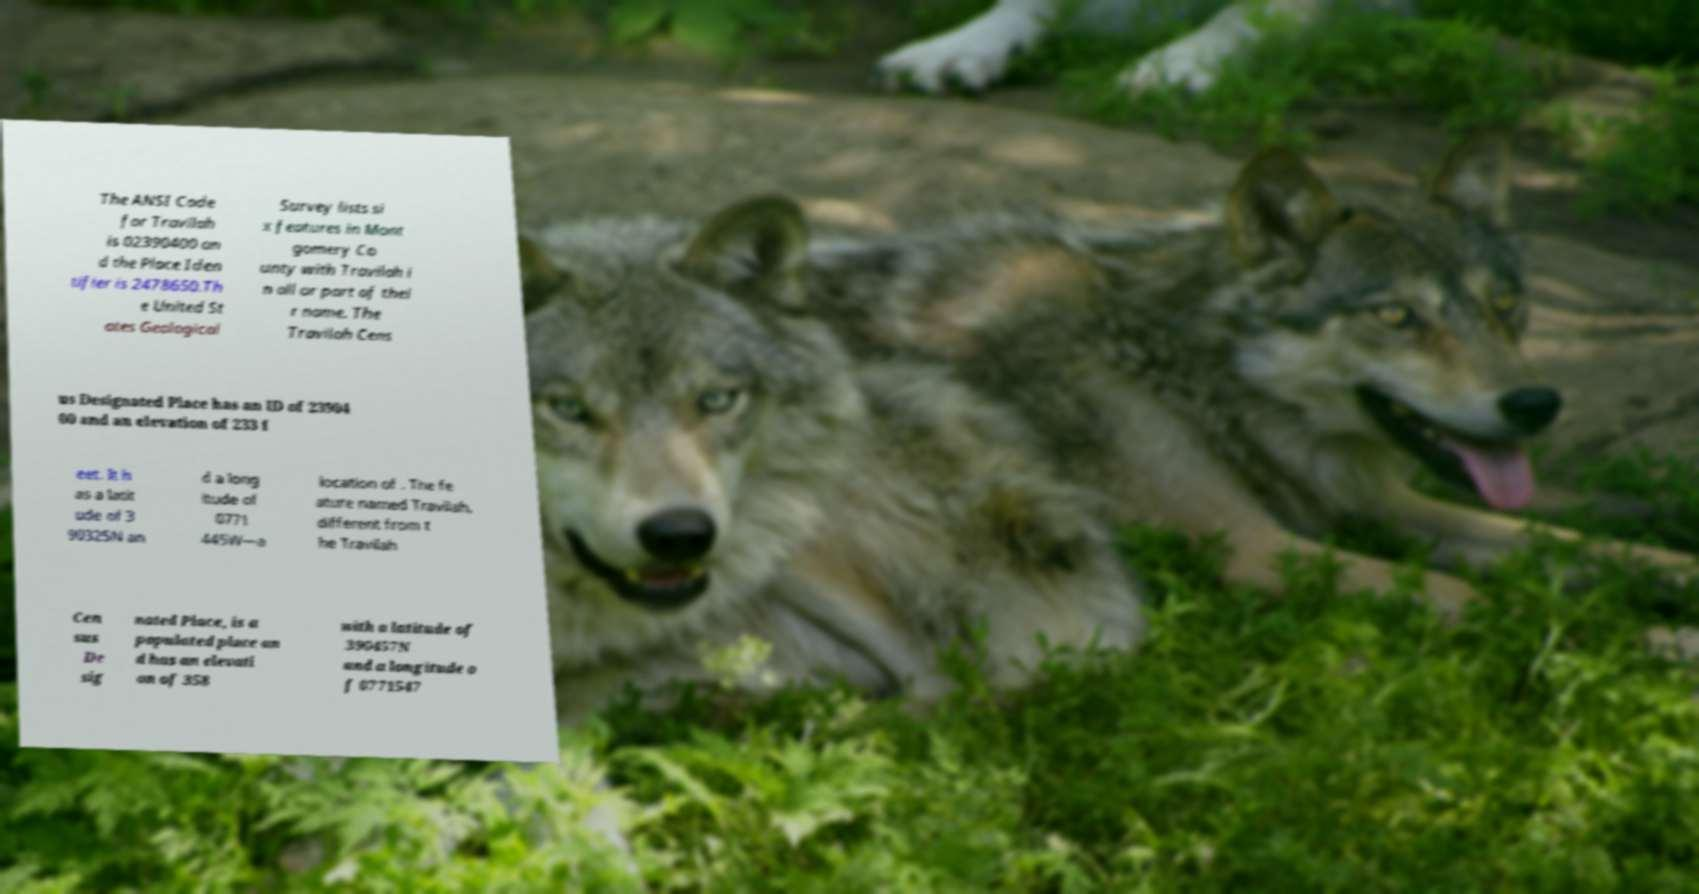What messages or text are displayed in this image? I need them in a readable, typed format. The ANSI Code for Travilah is 02390400 an d the Place Iden tifier is 2478650.Th e United St ates Geological Survey lists si x features in Mont gomery Co unty with Travilah i n all or part of thei r name. The Travilah Cens us Designated Place has an ID of 23904 00 and an elevation of 233 f eet. It h as a latit ude of 3 90325N an d a long itude of 0771 445W—a location of . The fe ature named Travilah, different from t he Travilah Cen sus De sig nated Place, is a populated place an d has an elevati on of 358 with a latitude of 390457N and a longitude o f 0771547 